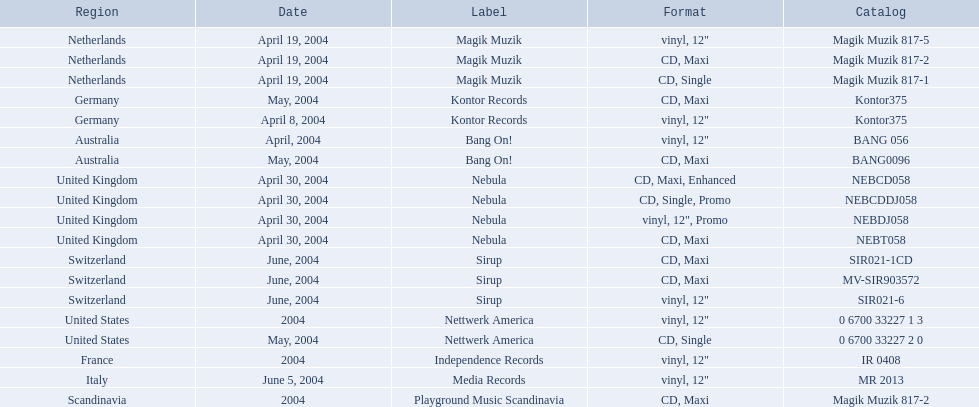Which label did the netherlands utilize for "love comes again"? Magik Muzik. Which label did germany employ? Kontor Records. Which label was applied in france? Independence Records. In "love comes again," what was the label associated with the netherlands? Magik Muzik. Germany? Kontor Records. France? Independence Records. 